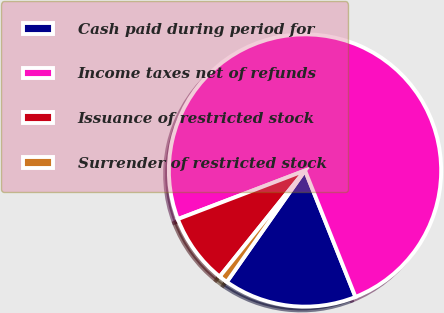Convert chart to OTSL. <chart><loc_0><loc_0><loc_500><loc_500><pie_chart><fcel>Cash paid during period for<fcel>Income taxes net of refunds<fcel>Issuance of restricted stock<fcel>Surrender of restricted stock<nl><fcel>15.78%<fcel>74.77%<fcel>8.41%<fcel>1.04%<nl></chart> 